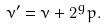<formula> <loc_0><loc_0><loc_500><loc_500>\nu ^ { \prime } = \nu + 2 ^ { g } p .</formula> 